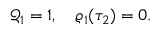<formula> <loc_0><loc_0><loc_500><loc_500>\begin{array} { r } { \mathcal { Q } _ { 1 } = 1 , \quad \varrho _ { 1 } ( \tau _ { 2 } ) = 0 . } \end{array}</formula> 